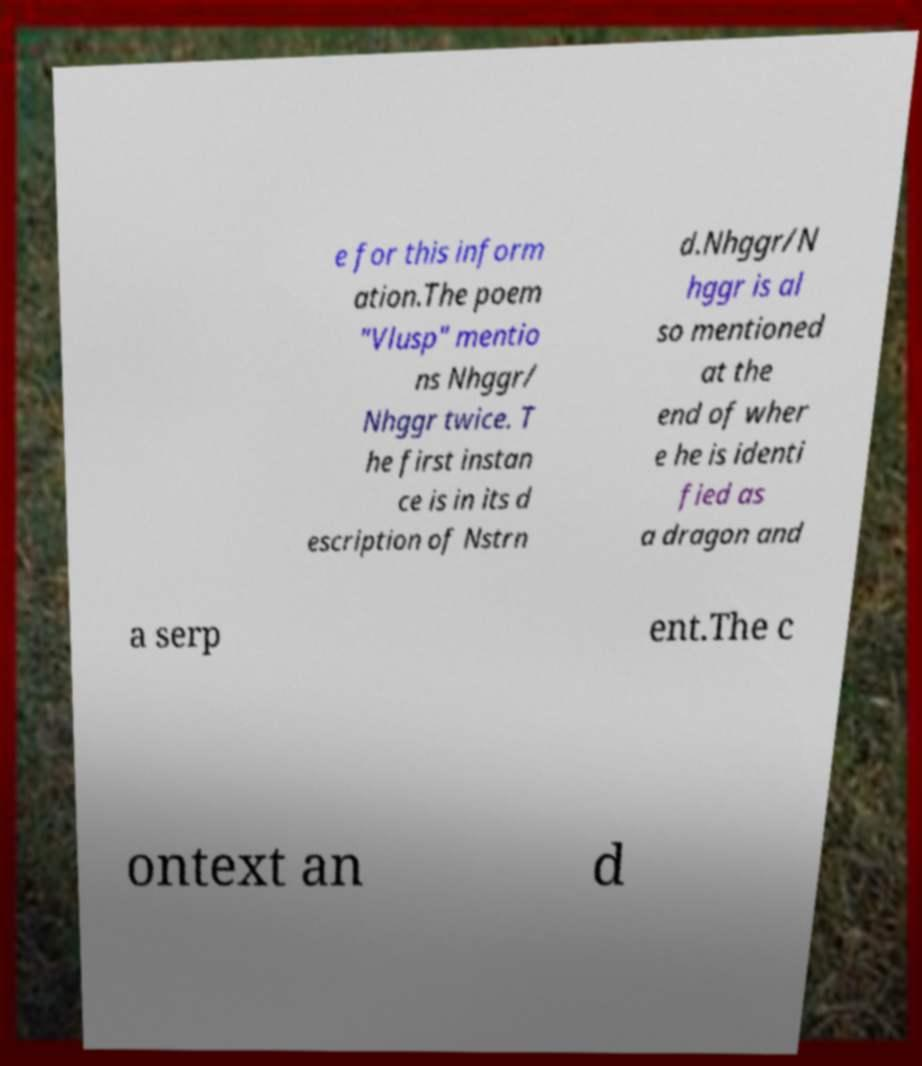Could you assist in decoding the text presented in this image and type it out clearly? e for this inform ation.The poem "Vlusp" mentio ns Nhggr/ Nhggr twice. T he first instan ce is in its d escription of Nstrn d.Nhggr/N hggr is al so mentioned at the end of wher e he is identi fied as a dragon and a serp ent.The c ontext an d 